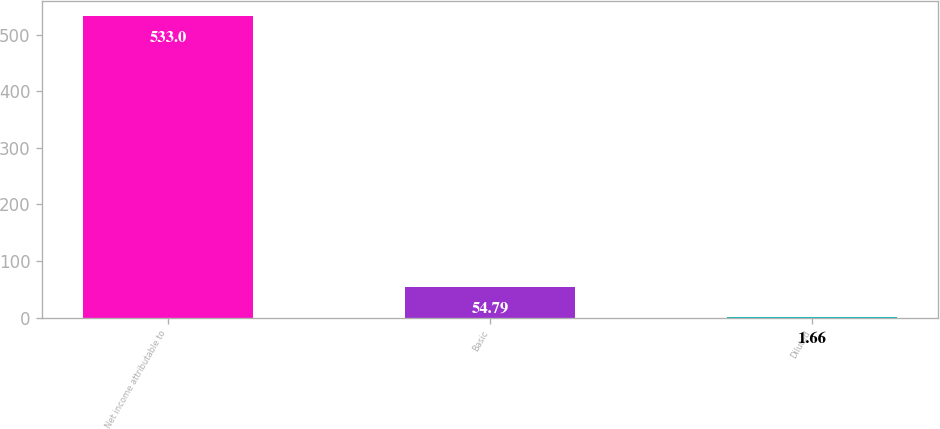Convert chart. <chart><loc_0><loc_0><loc_500><loc_500><bar_chart><fcel>Net income attributable to<fcel>Basic<fcel>Diluted<nl><fcel>533<fcel>54.79<fcel>1.66<nl></chart> 